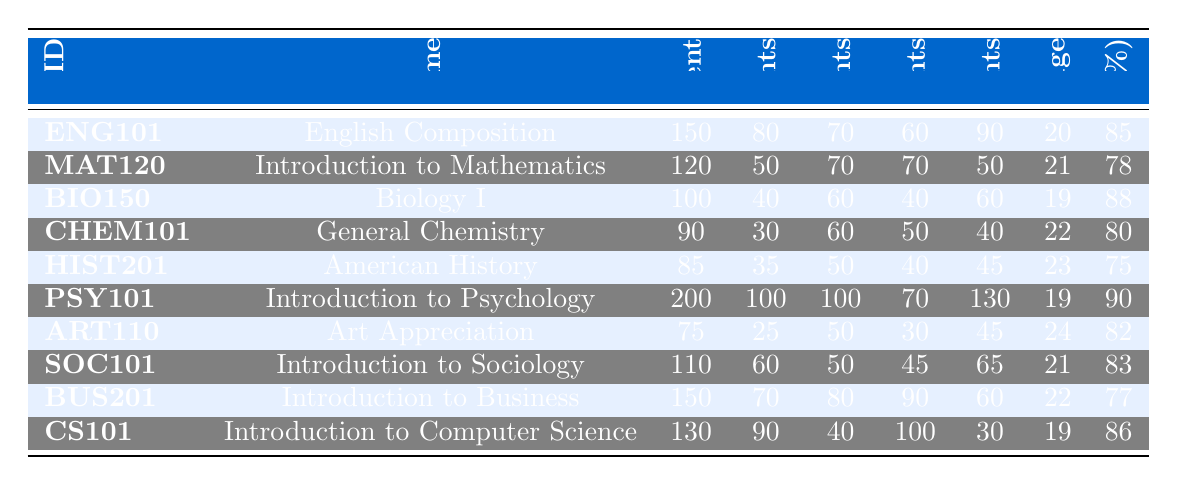What is the total enrollment for the course "Biology I"? From the table, the total enrollment for "Biology I" (BIO150) is directly listed as 100.
Answer: 100 Which course has the highest completion rate? Looking at the completion rates in the table, "Introduction to Psychology" (PSY101) has the highest rate at 90%.
Answer: Introduction to Psychology How many male students are enrolled in "General Chemistry"? The number of male students enrolled in "General Chemistry" (CHEM101) is listed in the table as 50.
Answer: 50 What is the average age of students in "Art Appreciation"? The average age for students in the course "Art Appreciation" (ART110) is shown as 24 years.
Answer: 24 What is the difference in total enrollment between "English Composition" and "Introduction to Mathematics"? The total enrollment for "English Composition" is 150, and for "Introduction to Mathematics" it is 120. The difference is 150 - 120 = 30.
Answer: 30 How many more female students are there in "Introduction to Psychology" than in "Biology I"? "Introduction to Psychology" has 130 female students, while "Biology I" has 60. The difference is 130 - 60 = 70.
Answer: 70 What percentage of the students in "American History" are full-time? There are 85 total students in "American History," with 35 being full-time. The percentage is (35 / 85) * 100 = 41.18%, which rounds to approximately 41% when considering whole numbers.
Answer: 41% Is the average age of students in "English Composition" higher than that in "Biology I"? The average age of students in "English Composition" is 20 years, while in "Biology I" it is 19 years. Since 20 > 19, the answer is yes.
Answer: Yes Which course has more part-time students, "Introduction to Business" or "CS101"? "Introduction to Business" has 80 part-time students, whereas "CS101" has 40. Since 80 > 40, "Introduction to Business" has more part-time students.
Answer: Introduction to Business If you combine the total enrollments of "MAT120" and "HIST201", what is the sum? The total enrollment for "MAT120" is 120 and for "HIST201" is 85. The sum is 120 + 85 = 205.
Answer: 205 What is the ratio of full-time students to total students in "Introduction to Sociology"? "Introduction to Sociology" has 60 full-time students out of a total of 110. The ratio is 60:110, which simplifies to 6:11.
Answer: 6:11 